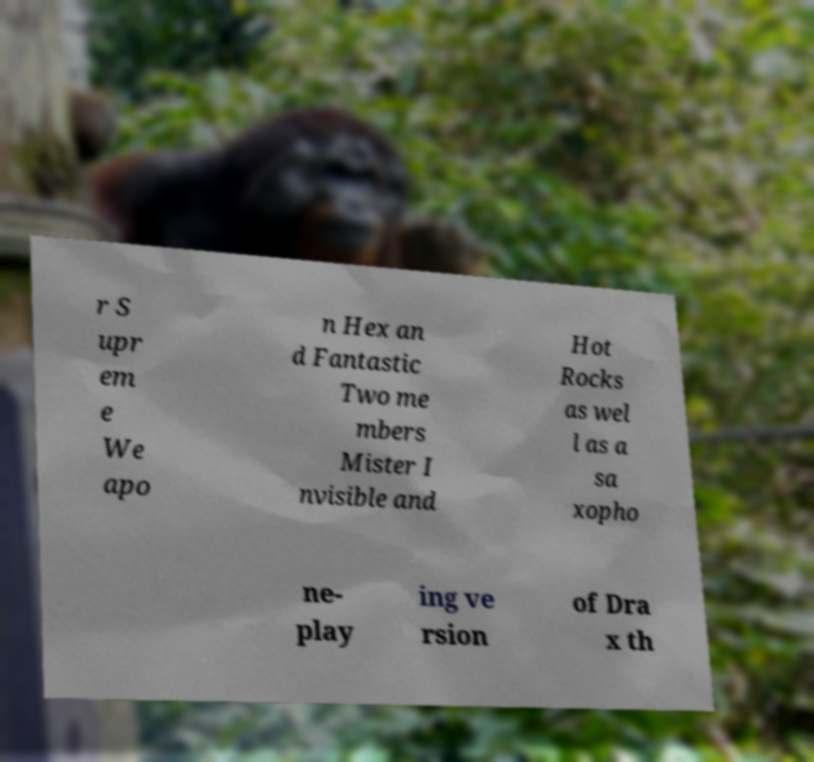Could you assist in decoding the text presented in this image and type it out clearly? r S upr em e We apo n Hex an d Fantastic Two me mbers Mister I nvisible and Hot Rocks as wel l as a sa xopho ne- play ing ve rsion of Dra x th 